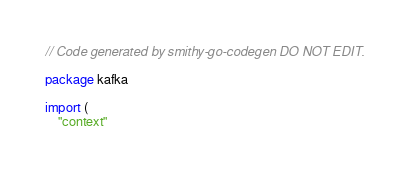Convert code to text. <code><loc_0><loc_0><loc_500><loc_500><_Go_>// Code generated by smithy-go-codegen DO NOT EDIT.

package kafka

import (
	"context"</code> 